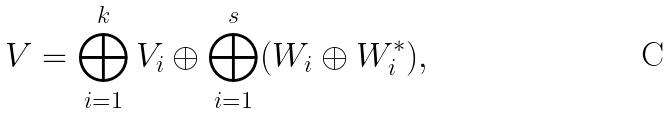Convert formula to latex. <formula><loc_0><loc_0><loc_500><loc_500>V = \bigoplus _ { i = 1 } ^ { k } V _ { i } \oplus \bigoplus _ { i = 1 } ^ { s } ( W _ { i } \oplus W _ { i } ^ { * } ) ,</formula> 